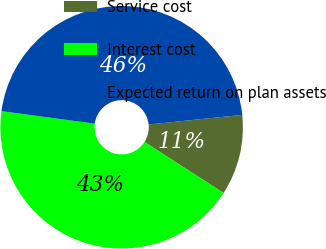<chart> <loc_0><loc_0><loc_500><loc_500><pie_chart><fcel>Service cost<fcel>Interest cost<fcel>Expected return on plan assets<nl><fcel>10.75%<fcel>43.01%<fcel>46.24%<nl></chart> 